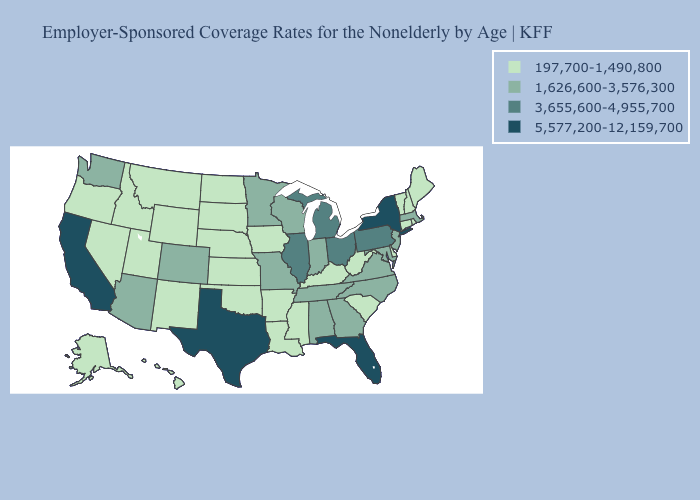Name the states that have a value in the range 3,655,600-4,955,700?
Concise answer only. Illinois, Michigan, Ohio, Pennsylvania. Among the states that border Connecticut , which have the highest value?
Quick response, please. New York. Name the states that have a value in the range 5,577,200-12,159,700?
Short answer required. California, Florida, New York, Texas. What is the highest value in the USA?
Quick response, please. 5,577,200-12,159,700. Does the map have missing data?
Be succinct. No. Does Illinois have a higher value than North Dakota?
Write a very short answer. Yes. What is the highest value in states that border Wisconsin?
Quick response, please. 3,655,600-4,955,700. Name the states that have a value in the range 5,577,200-12,159,700?
Give a very brief answer. California, Florida, New York, Texas. Does the map have missing data?
Quick response, please. No. Name the states that have a value in the range 197,700-1,490,800?
Be succinct. Alaska, Arkansas, Connecticut, Delaware, Hawaii, Idaho, Iowa, Kansas, Kentucky, Louisiana, Maine, Mississippi, Montana, Nebraska, Nevada, New Hampshire, New Mexico, North Dakota, Oklahoma, Oregon, Rhode Island, South Carolina, South Dakota, Utah, Vermont, West Virginia, Wyoming. Name the states that have a value in the range 197,700-1,490,800?
Give a very brief answer. Alaska, Arkansas, Connecticut, Delaware, Hawaii, Idaho, Iowa, Kansas, Kentucky, Louisiana, Maine, Mississippi, Montana, Nebraska, Nevada, New Hampshire, New Mexico, North Dakota, Oklahoma, Oregon, Rhode Island, South Carolina, South Dakota, Utah, Vermont, West Virginia, Wyoming. What is the lowest value in the USA?
Keep it brief. 197,700-1,490,800. Name the states that have a value in the range 197,700-1,490,800?
Write a very short answer. Alaska, Arkansas, Connecticut, Delaware, Hawaii, Idaho, Iowa, Kansas, Kentucky, Louisiana, Maine, Mississippi, Montana, Nebraska, Nevada, New Hampshire, New Mexico, North Dakota, Oklahoma, Oregon, Rhode Island, South Carolina, South Dakota, Utah, Vermont, West Virginia, Wyoming. Does the first symbol in the legend represent the smallest category?
Keep it brief. Yes. What is the lowest value in the West?
Be succinct. 197,700-1,490,800. 